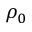<formula> <loc_0><loc_0><loc_500><loc_500>\rho _ { 0 }</formula> 